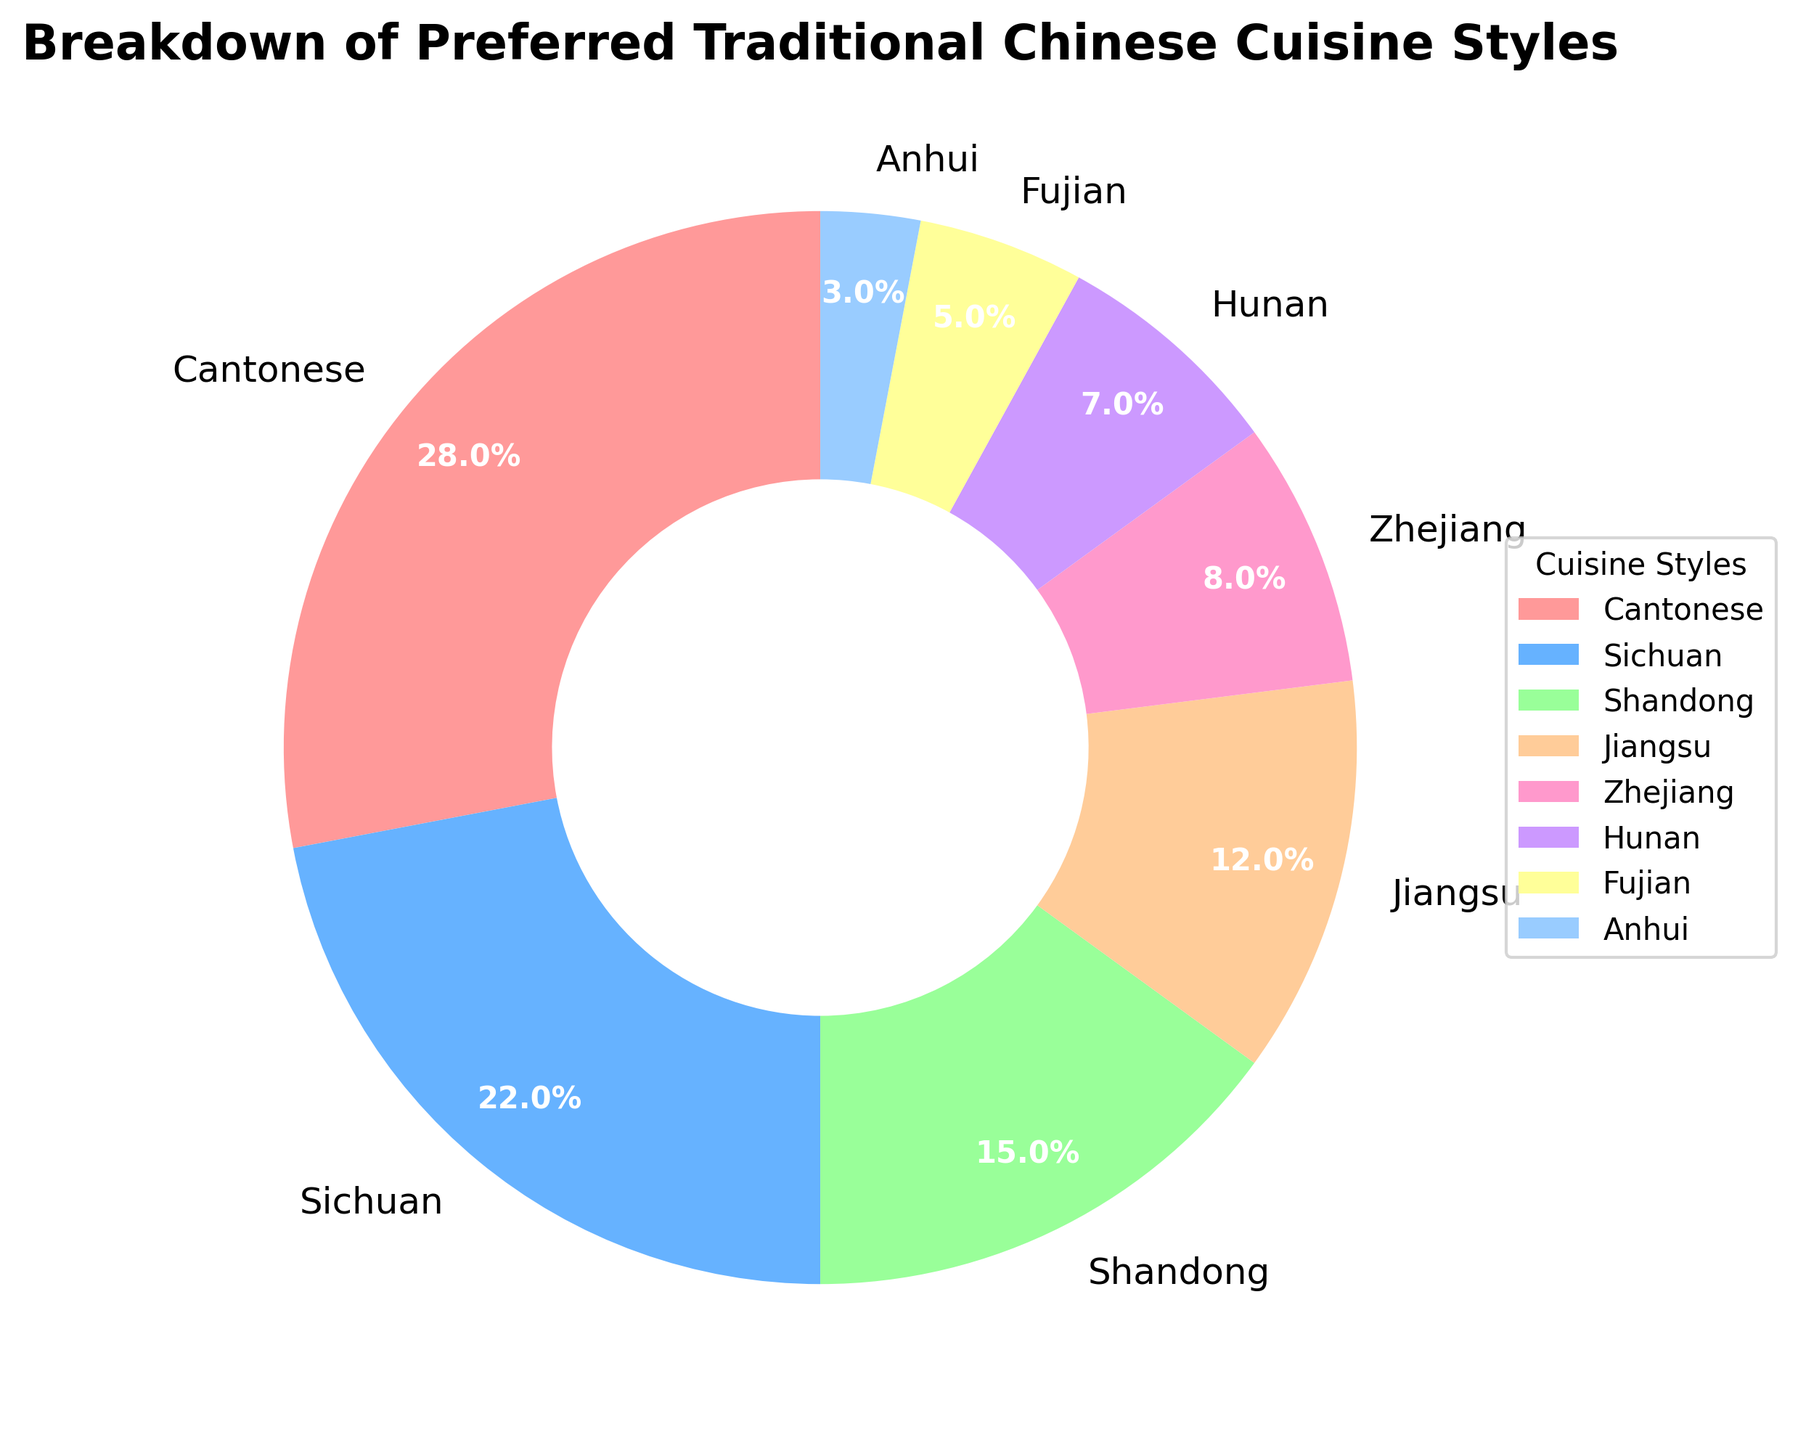What percentage of people prefer Cantonese cuisine? The figure shows that the wedge labeled with "Cantonese" represents the largest section of the pie chart. The label indicates that this section accounts for 28% of the preferences.
Answer: 28% Which cuisine style is preferred the least, and what is its percentage? The smallest wedge in the pie chart is labeled "Anhui", and it accounts for 3% of the preferences.
Answer: Anhui, 3% How does the preference for Sichuan cuisine compare to that for Shandong cuisine? The pie chart shows that the Sichuan section occupies 22% of the chart while the Shandong section accounts for 15%. Thus, preference for Sichuan cuisine is higher than for Shandong.
Answer: Sichuan is preferred 7% more than Shandong What is the combined percentage of people preferring Jiangsu and Zhejiang cuisines? The pie chart shows that Jiangsu cuisine accounts for 12%, and Zhejiang cuisine accounts for 8%. Adding these percentages gives 12% + 8%, which totals to 20%.
Answer: 20% By how much does the preference for Jiangsu cuisine exceed that of Hunan cuisine? Jiangsu cuisine has a preference percentage of 12%, while Hunan cuisine has 7%. The difference is calculated as 12% - 7% = 5%.
Answer: 5% Which cuisine styles are preferred by more than 20% of people? According to the pie chart, only Cantonese (28%) and Sichuan (22%) cuisines exceed the 20% preference threshold.
Answer: Cantonese and Sichuan What is the total percentage of preferences for the three least preferred cuisine styles? The three least preferred cuisine styles and their percentages are Anhui (3%), Fujian (5%), and Hunan (7%). Summing these values gives 3% + 5% + 7% = 15%.
Answer: 15% What are the two colors representing cuisines that make up exactly 20% of the preferences combined? The pie chart shows that Jiangsu (12%) is represented in orange, and Zhejiang (8%) is represented in pink. Together, they make up 20%.
Answer: Orange and pink How does the combined percentage of Anhui and Fujian cuisines compare to Zhejiang cuisine? Anhui accounts for 3% and Fujian for 5%, together making 8%. This is equal to the preference percentage for Zhejiang cuisine, which is also 8%.
Answer: Equal Which cuisine styles are represented by wedges of warm colors, and what are their percentages? In the pie chart, warm colors like shades of red, pink, and orange represent Cantonese (28%), Jiangsu (12%), and Fujian (5%). Summing these percentages gives 28% + 12% + 5% = 45%.
Answer: Cantonese, Jiangsu, and Fujian, 45% 